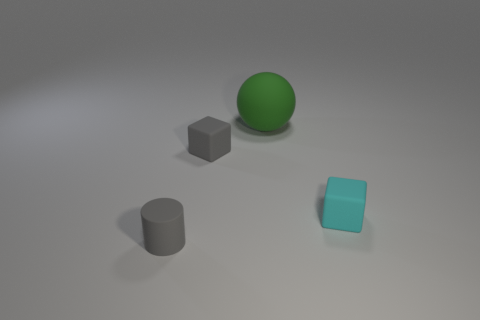Add 3 small purple matte cylinders. How many objects exist? 7 Subtract all cylinders. How many objects are left? 3 Add 2 small gray matte blocks. How many small gray matte blocks are left? 3 Add 3 rubber cubes. How many rubber cubes exist? 5 Subtract 0 red cylinders. How many objects are left? 4 Subtract all small rubber things. Subtract all gray rubber cylinders. How many objects are left? 0 